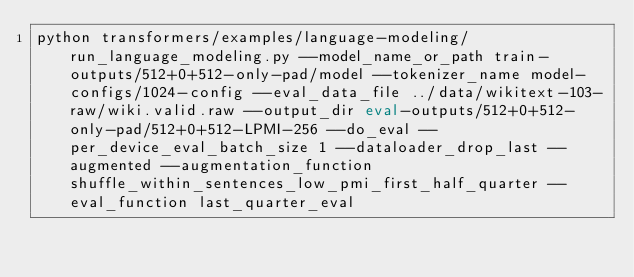Convert code to text. <code><loc_0><loc_0><loc_500><loc_500><_Bash_>python transformers/examples/language-modeling/run_language_modeling.py --model_name_or_path train-outputs/512+0+512-only-pad/model --tokenizer_name model-configs/1024-config --eval_data_file ../data/wikitext-103-raw/wiki.valid.raw --output_dir eval-outputs/512+0+512-only-pad/512+0+512-LPMI-256 --do_eval --per_device_eval_batch_size 1 --dataloader_drop_last --augmented --augmentation_function shuffle_within_sentences_low_pmi_first_half_quarter --eval_function last_quarter_eval</code> 